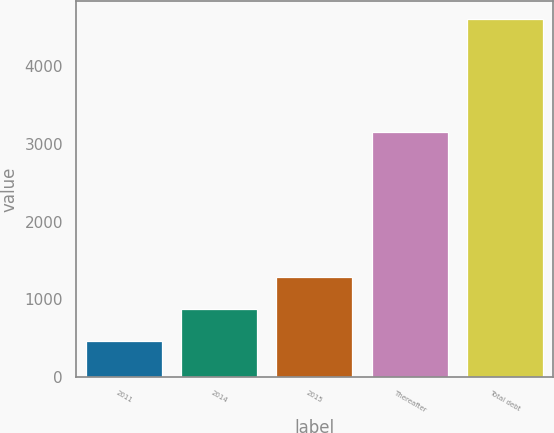Convert chart to OTSL. <chart><loc_0><loc_0><loc_500><loc_500><bar_chart><fcel>2011<fcel>2014<fcel>2015<fcel>Thereafter<fcel>Total debt<nl><fcel>463<fcel>877.9<fcel>1292.8<fcel>3152<fcel>4612<nl></chart> 